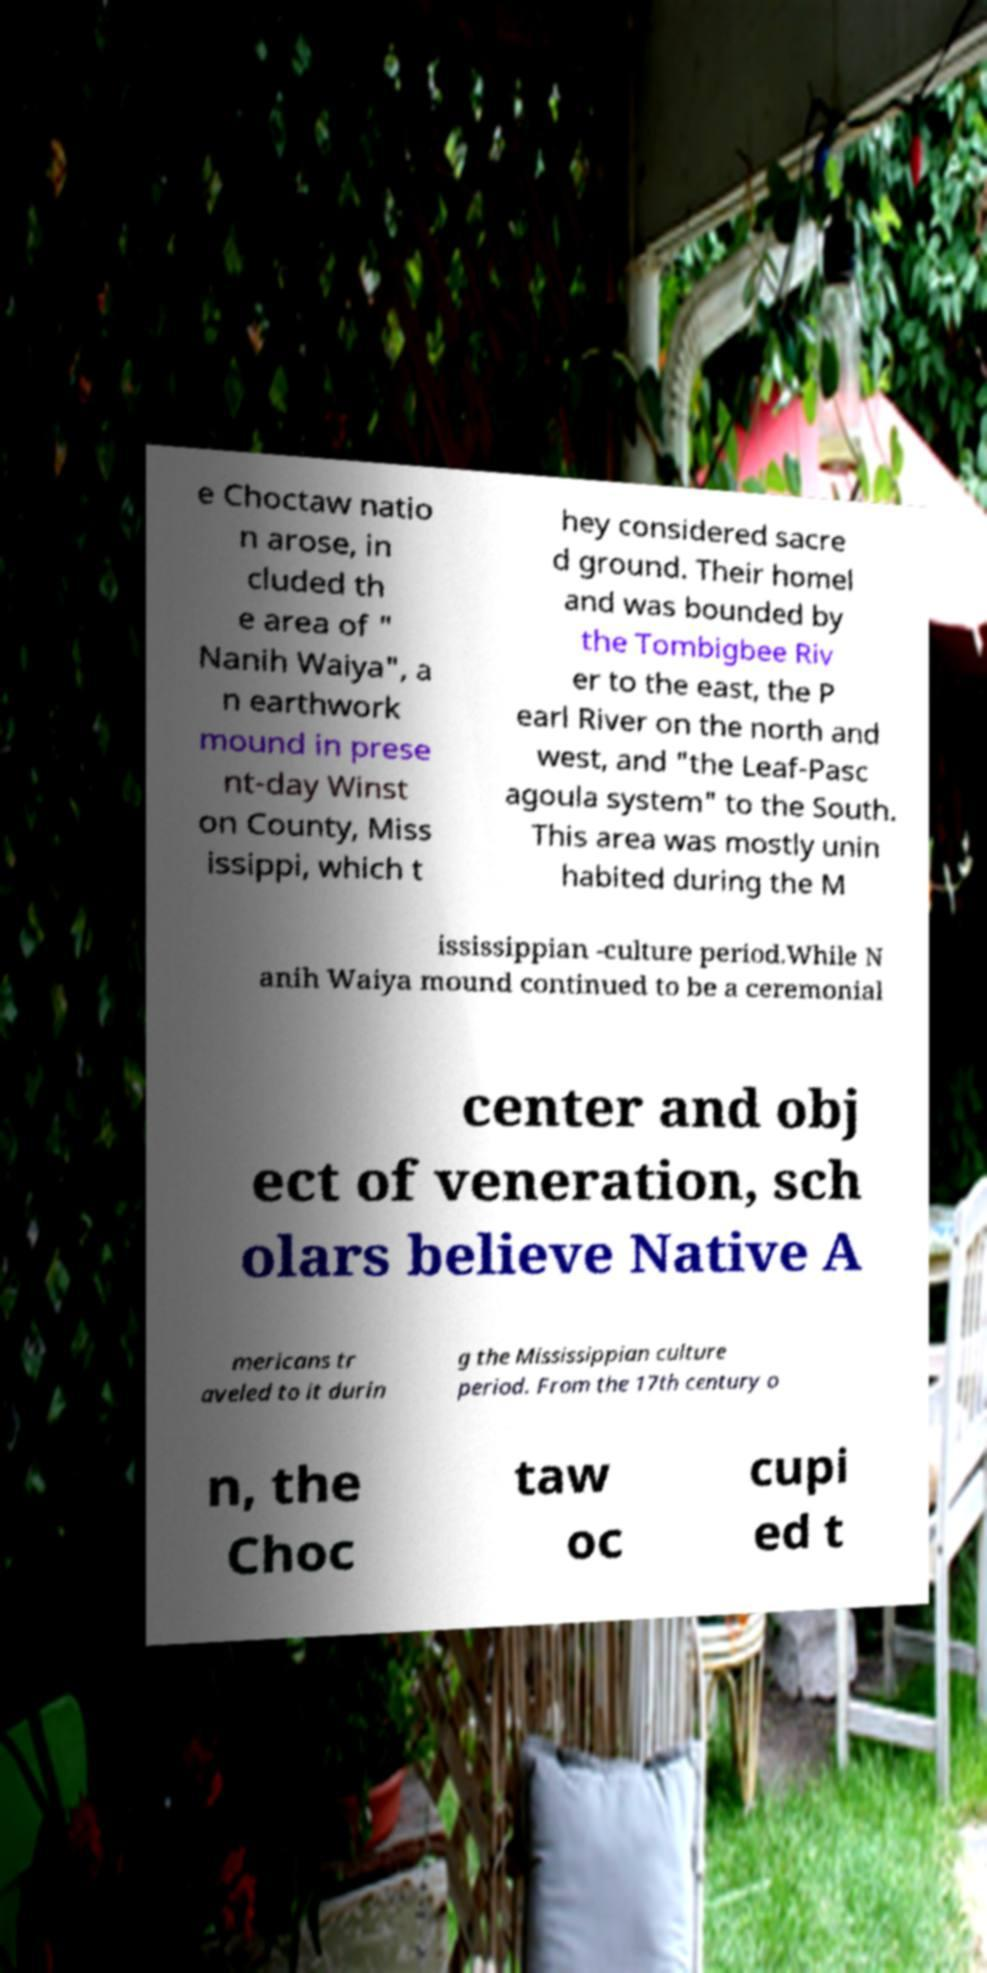Could you extract and type out the text from this image? e Choctaw natio n arose, in cluded th e area of " Nanih Waiya", a n earthwork mound in prese nt-day Winst on County, Miss issippi, which t hey considered sacre d ground. Their homel and was bounded by the Tombigbee Riv er to the east, the P earl River on the north and west, and "the Leaf-Pasc agoula system" to the South. This area was mostly unin habited during the M ississippian -culture period.While N anih Waiya mound continued to be a ceremonial center and obj ect of veneration, sch olars believe Native A mericans tr aveled to it durin g the Mississippian culture period. From the 17th century o n, the Choc taw oc cupi ed t 